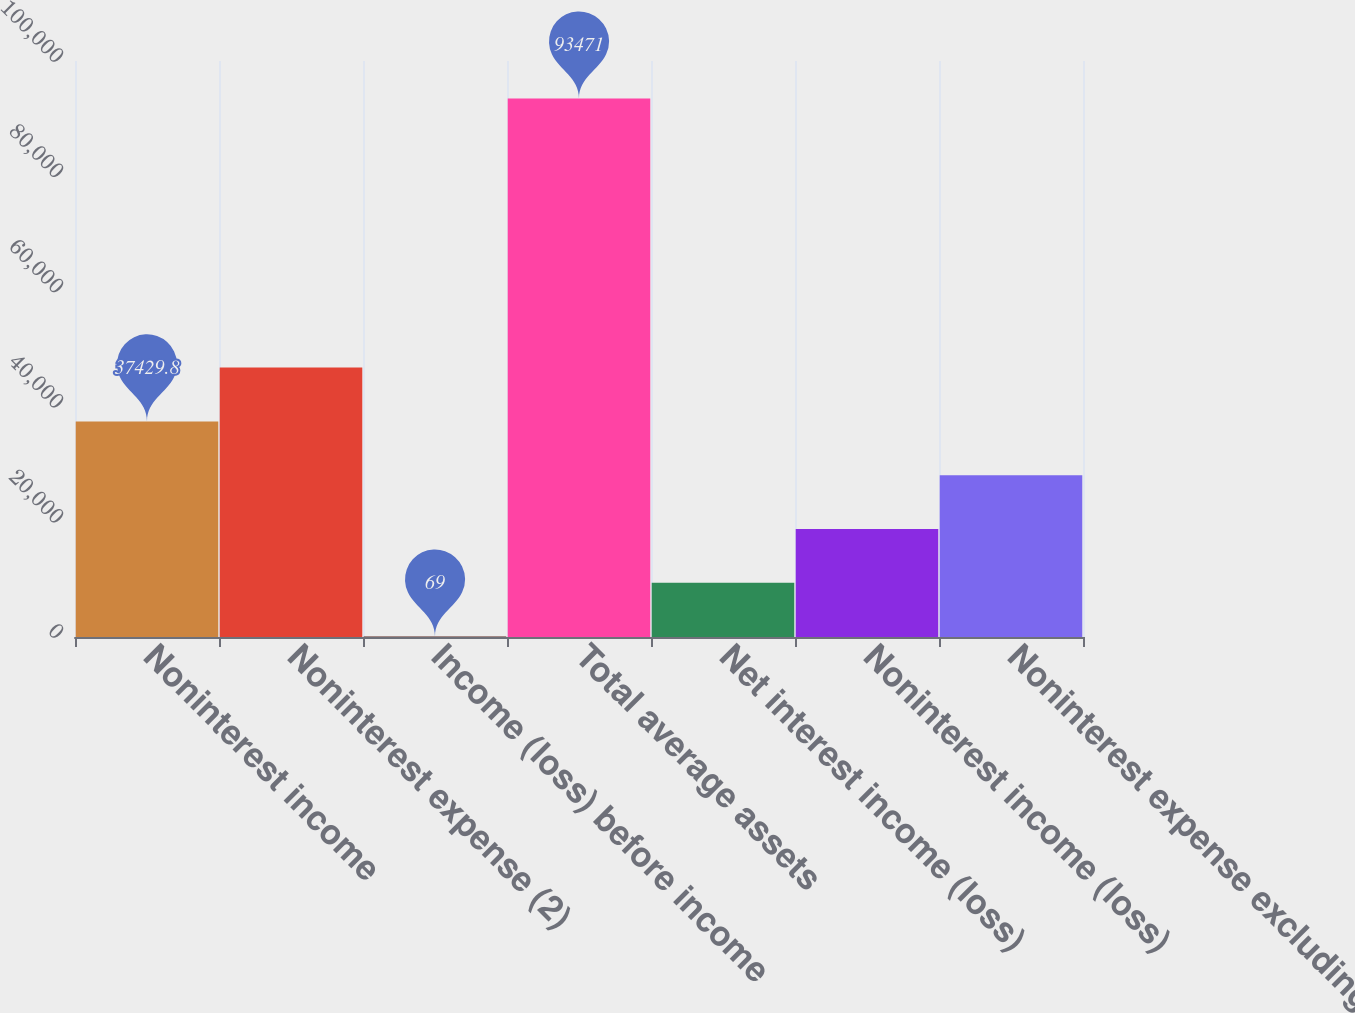Convert chart to OTSL. <chart><loc_0><loc_0><loc_500><loc_500><bar_chart><fcel>Noninterest income<fcel>Noninterest expense (2)<fcel>Income (loss) before income<fcel>Total average assets<fcel>Net interest income (loss)<fcel>Noninterest income (loss)<fcel>Noninterest expense excluding<nl><fcel>37429.8<fcel>46770<fcel>69<fcel>93471<fcel>9409.2<fcel>18749.4<fcel>28089.6<nl></chart> 